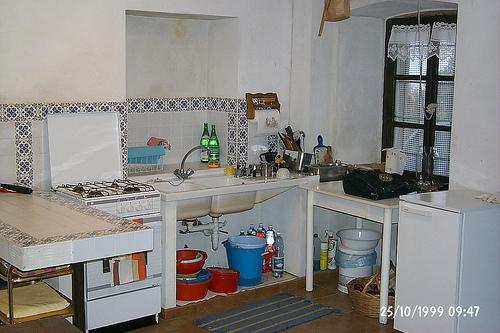Question: why is there buckets under the sink?
Choices:
A. To put items in.
B. To hold tools.
C. To keep extra items.
D. To hold water.
Answer with the letter. Answer: D Question: where is this location?
Choices:
A. Kitchen.
B. Bathroom.
C. Bedroom.
D. Living room.
Answer with the letter. Answer: A Question: when was the picture taken?
Choices:
A. Day time.
B. Night.
C. Dusk.
D. Dawn.
Answer with the letter. Answer: A 